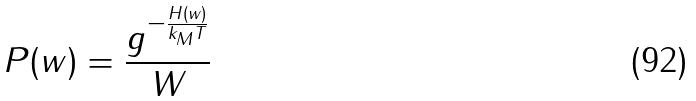<formula> <loc_0><loc_0><loc_500><loc_500>P ( w ) = \frac { g ^ { - \frac { H ( w ) } { k _ { M } T } } } { W }</formula> 